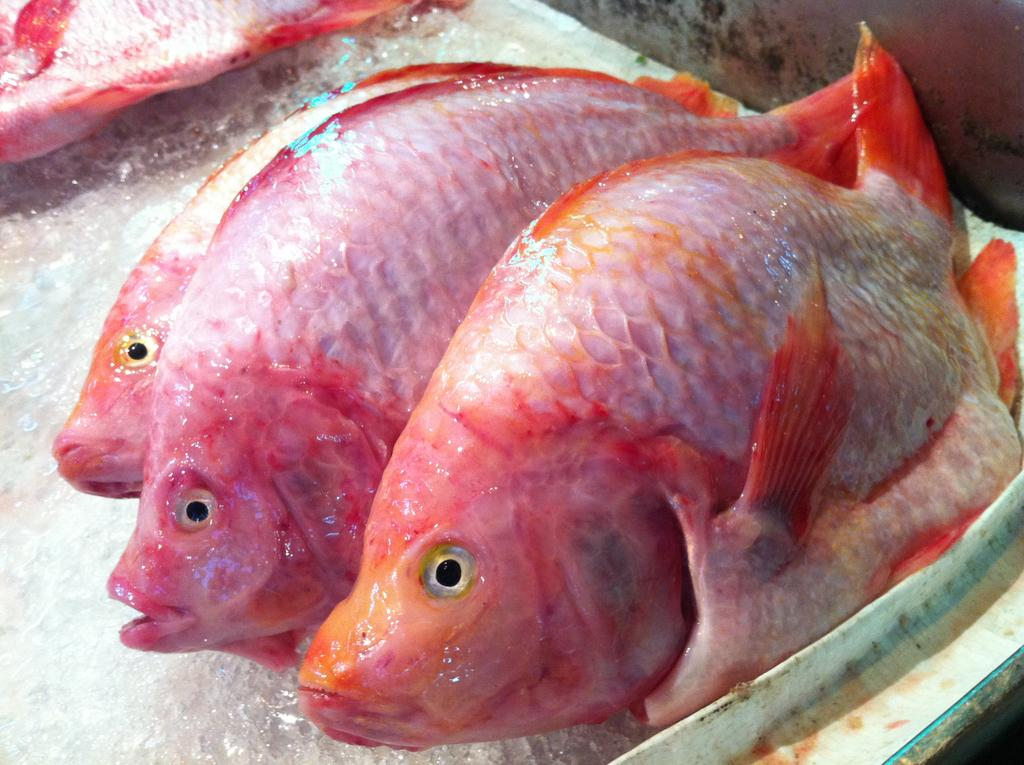What type of animals can be seen in the image? There are fishes in the image. What is the container made of, and what color is it? The container is made of a white color material. What type of drug is being administered to the fishes in the image? There is no indication of any drug being administered to the fishes in the image. 